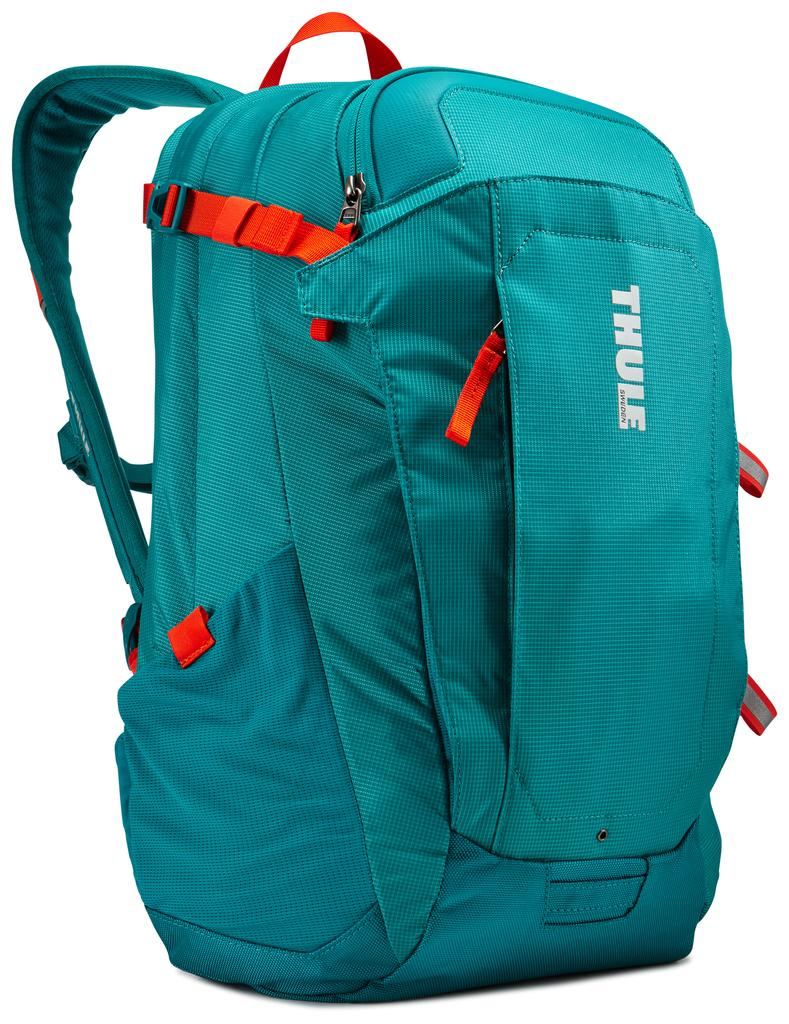What object can be seen in the image? There is a bag in the image. What color is the bag? The bag is blue in color. What brand name is associated with the bag? The brand name of the bag is "Thule." What flavor of ice cream is being served in the bag? There is no ice cream or serving mentioned in the image, and the bag is not associated with any flavor. 